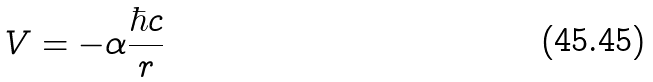<formula> <loc_0><loc_0><loc_500><loc_500>V = - \alpha \frac { \hbar { c } } { r }</formula> 